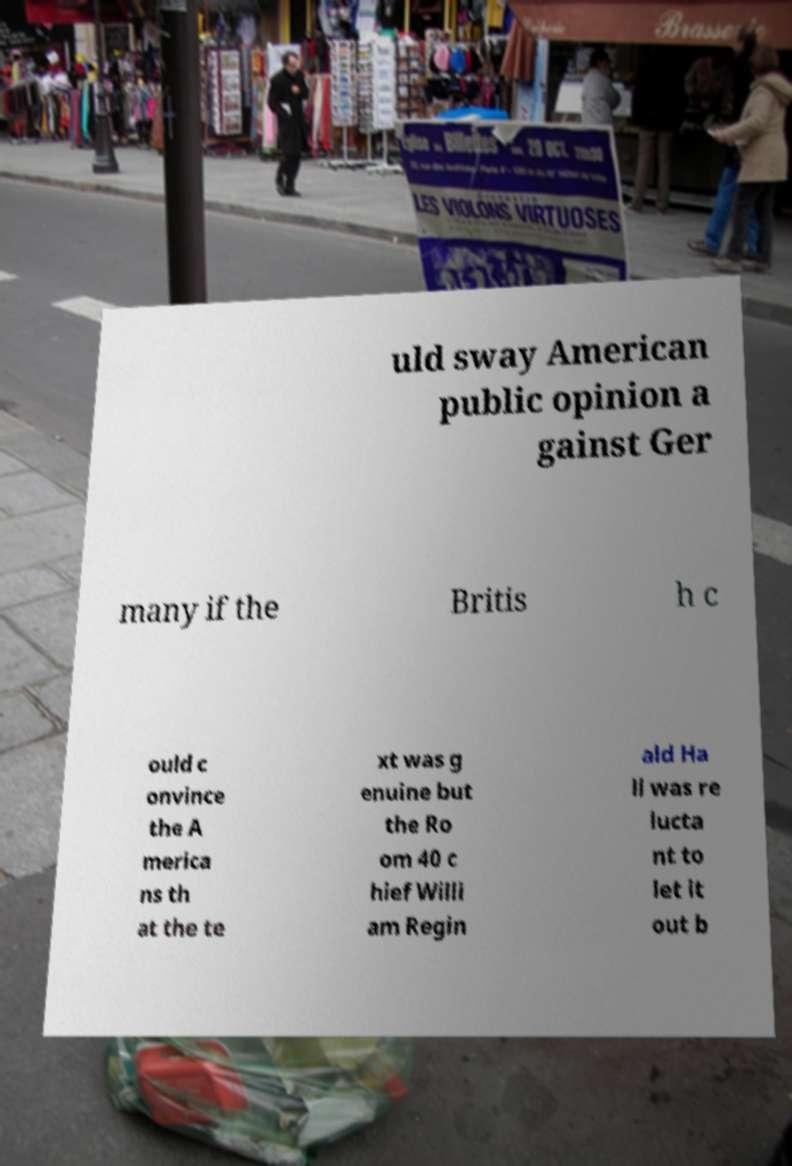Please identify and transcribe the text found in this image. uld sway American public opinion a gainst Ger many if the Britis h c ould c onvince the A merica ns th at the te xt was g enuine but the Ro om 40 c hief Willi am Regin ald Ha ll was re lucta nt to let it out b 